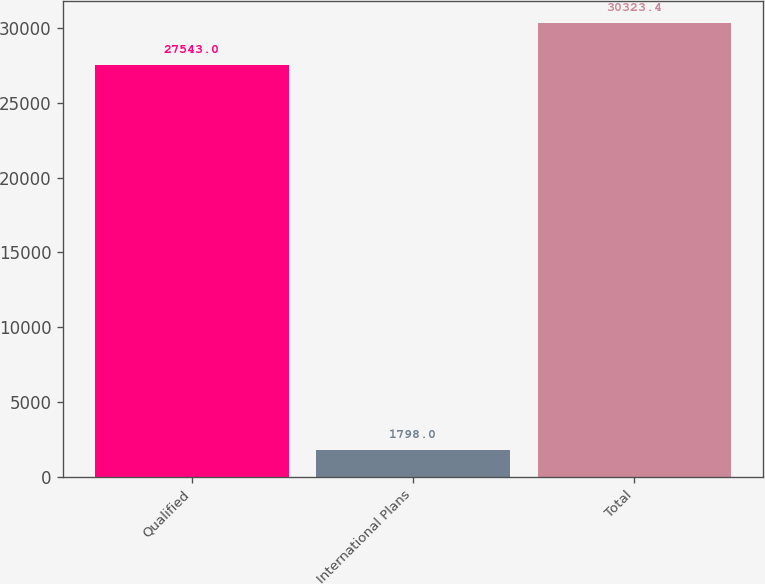Convert chart to OTSL. <chart><loc_0><loc_0><loc_500><loc_500><bar_chart><fcel>Qualified<fcel>International Plans<fcel>Total<nl><fcel>27543<fcel>1798<fcel>30323.4<nl></chart> 